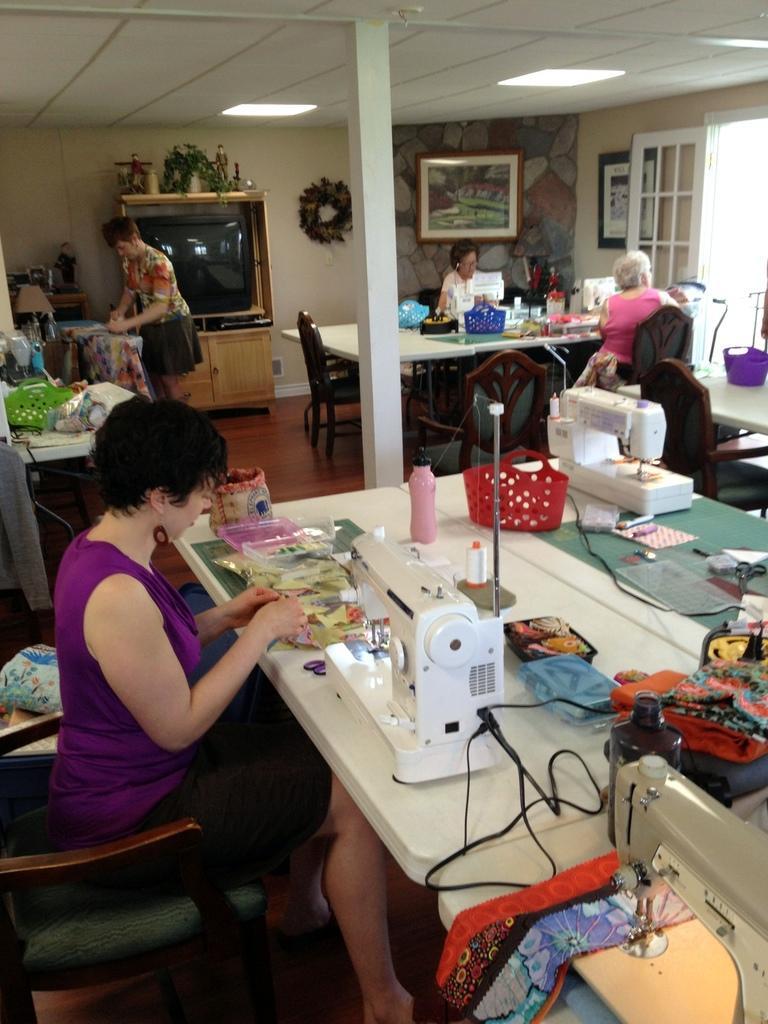How would you summarize this image in a sentence or two? In this picture there is a lady on the left side of the image in front of a table, table contains clothes and sewing machines on it, there are other people on the tables in the background area of the image, there are lamps at the top side of the image, there is a television and a window in the background area of the image. 